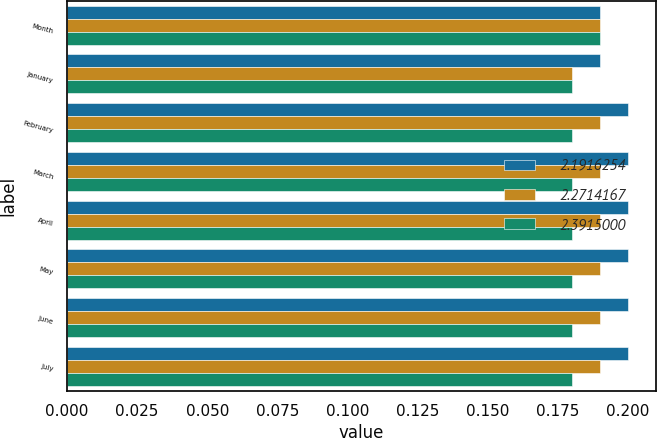Convert chart to OTSL. <chart><loc_0><loc_0><loc_500><loc_500><stacked_bar_chart><ecel><fcel>Month<fcel>January<fcel>February<fcel>March<fcel>April<fcel>May<fcel>June<fcel>July<nl><fcel>2.19163<fcel>0.19<fcel>0.19<fcel>0.2<fcel>0.2<fcel>0.2<fcel>0.2<fcel>0.2<fcel>0.2<nl><fcel>2.27142<fcel>0.19<fcel>0.18<fcel>0.19<fcel>0.19<fcel>0.19<fcel>0.19<fcel>0.19<fcel>0.19<nl><fcel>2.3915<fcel>0.19<fcel>0.18<fcel>0.18<fcel>0.18<fcel>0.18<fcel>0.18<fcel>0.18<fcel>0.18<nl></chart> 